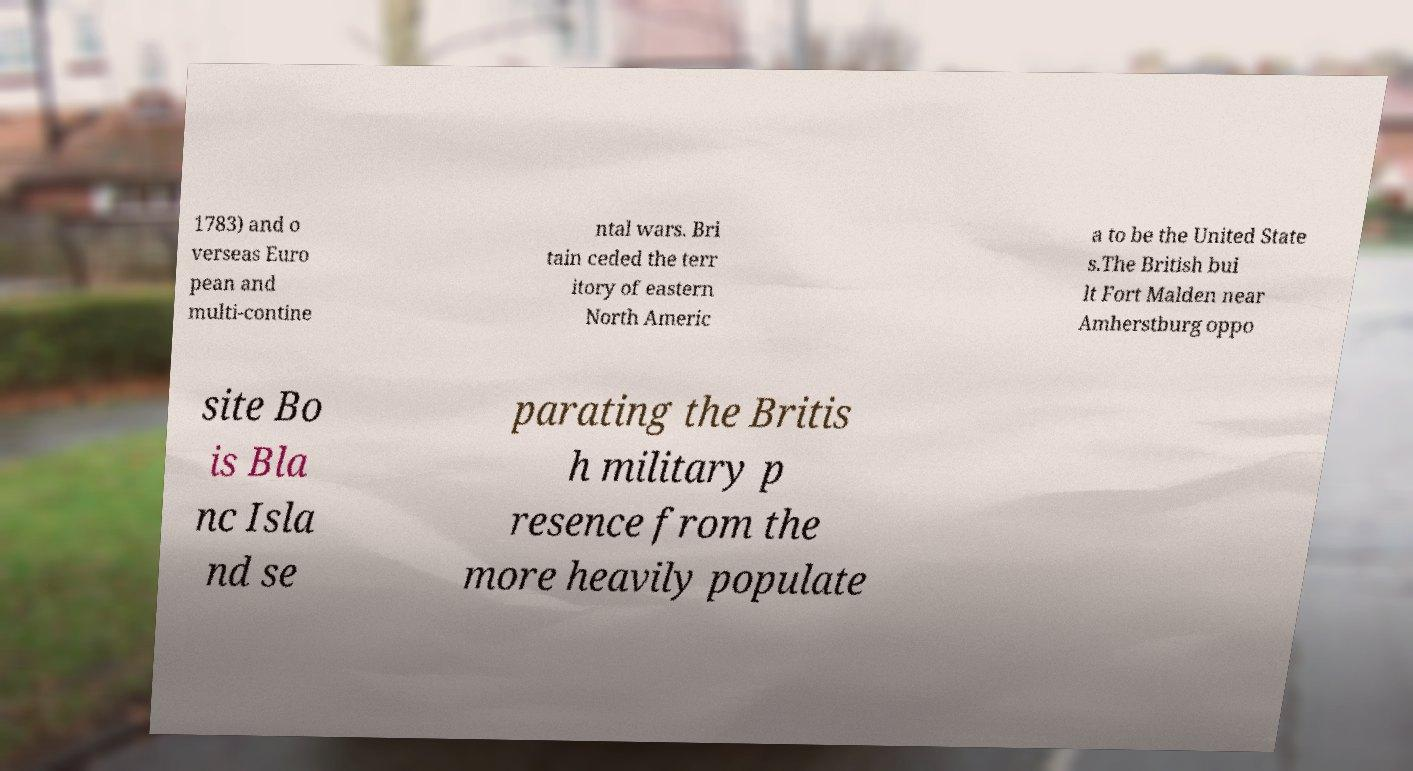Could you assist in decoding the text presented in this image and type it out clearly? 1783) and o verseas Euro pean and multi-contine ntal wars. Bri tain ceded the terr itory of eastern North Americ a to be the United State s.The British bui lt Fort Malden near Amherstburg oppo site Bo is Bla nc Isla nd se parating the Britis h military p resence from the more heavily populate 